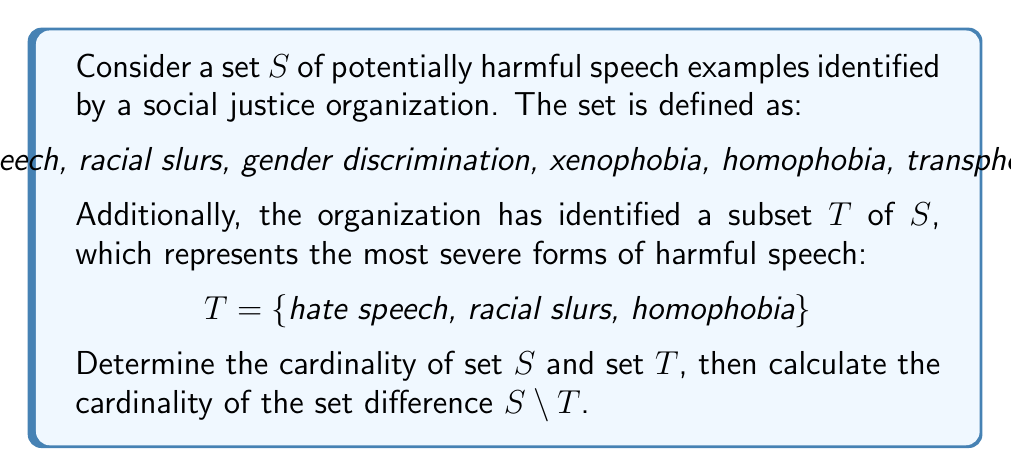Help me with this question. To solve this problem, we'll follow these steps:

1. Find the cardinality of set $S$:
   $|S| = 7$ (count the number of elements in $S$)

2. Find the cardinality of set $T$:
   $|T| = 3$ (count the number of elements in $T$)

3. Calculate the set difference $S \setminus T$:
   $S \setminus T = \{$gender discrimination, xenophobia, transphobia, ableism$\}$

4. Find the cardinality of $S \setminus T$:
   $|S \setminus T| = 4$ (count the number of elements in $S \setminus T$)

5. Verify the result using the set difference formula:
   $|S \setminus T| = |S| - |S \cap T|$
   $|S \cap T| = |T| = 3$ (since $T$ is a subset of $S$)
   $|S \setminus T| = 7 - 3 = 4$

This confirms our calculation in step 4.
Answer: $|S| = 7$, $|T| = 3$, $|S \setminus T| = 4$ 